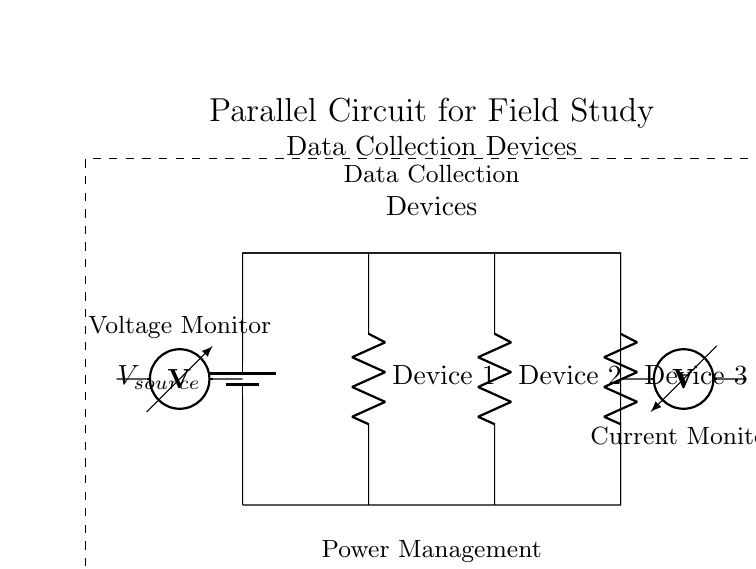What type of circuit is this? The circuit is a parallel circuit because multiple devices are connected alongside each other, sharing the same voltage source.
Answer: Parallel circuit How many resistive devices are shown? There are three resistive devices in the circuit, labeled as Device 1, Device 2, and Device 3.
Answer: Three What is the function of the ammeter? The ammeter is used to monitor the current flowing through the circuit, providing an indication of how much current each device is consuming.
Answer: Current Monitor What does the voltage monitor measure? The voltage monitor measures the voltage across the power source to ensure devices operate within appropriate voltage levels.
Answer: Voltage Monitor What would happen if one device fails? If one device fails, the other devices will continue to operate since they are in a parallel configuration, maintaining circuit functionality.
Answer: Others continue to operate What is the purpose of the power management system? The power management system is responsible for ensuring that the devices receive the correct voltage and can manage power distribution for optimal operation.
Answer: Power distribution What is the total voltage for all devices in this circuit? The total voltage is the same as the source voltage, as all devices in a parallel circuit maintain the same voltage across them.
Answer: Source voltage 